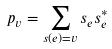Convert formula to latex. <formula><loc_0><loc_0><loc_500><loc_500>p _ { v } = \sum _ { s ( e ) = v } s _ { e } s _ { e } ^ { * }</formula> 